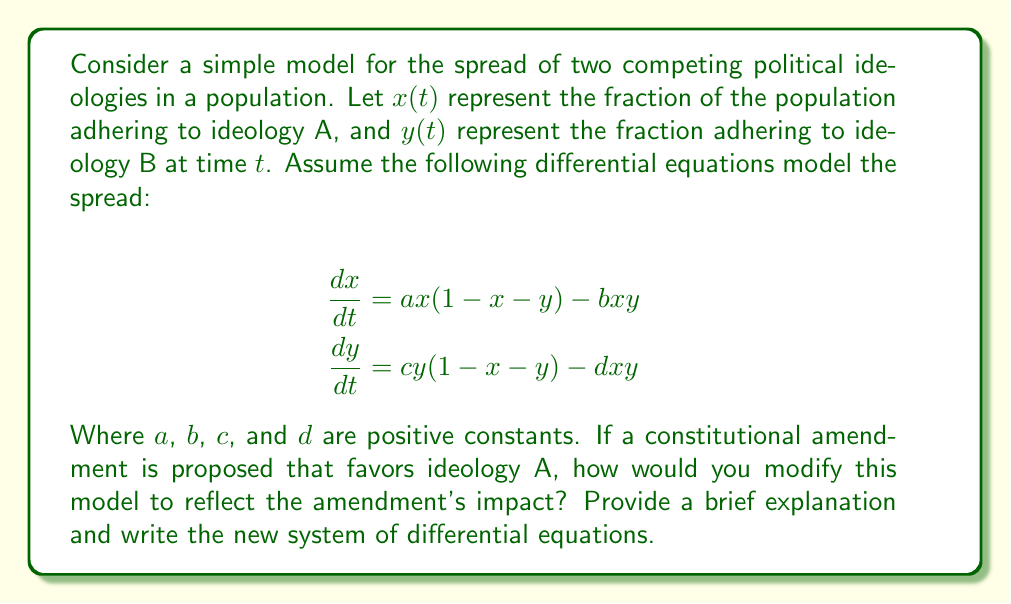Teach me how to tackle this problem. To modify the model to reflect the impact of a constitutional amendment favoring ideology A, we need to consider how it would affect the spread and interaction of the two ideologies:

1. The amendment would likely increase the rate at which ideology A spreads. This can be represented by increasing the coefficient $a$ to a new value $a'$, where $a' > a$.

2. The amendment might also make it harder for ideology B to spread, which can be represented by decreasing the coefficient $c$ to a new value $c'$, where $c' < c$.

3. The interaction terms ($bxy$ and $dxy$) might also be affected. The amendment could make it easier for ideology A to convert followers of ideology B, increasing $b$ to $b'$, where $b' > b$. Conversely, it might make it harder for ideology B to convert followers of ideology A, decreasing $d$ to $d'$, where $d' < d$.

4. The constraints on the population fractions ($1-x-y$) remain unchanged, as the total population is still normalized to 1.

Given these considerations, the new system of differential equations would be:

$$\frac{dx}{dt} = a'x(1-x-y) - b'xy$$
$$\frac{dy}{dt} = c'y(1-x-y) - d'xy$$

Where $a' > a$, $b' > b$, $c' < c$, and $d' < d$.
Answer: $$\frac{dx}{dt} = a'x(1-x-y) - b'xy$$
$$\frac{dy}{dt} = c'y(1-x-y) - d'xy$$
Where $a' > a$, $b' > b$, $c' < c$, $d' < d$ 